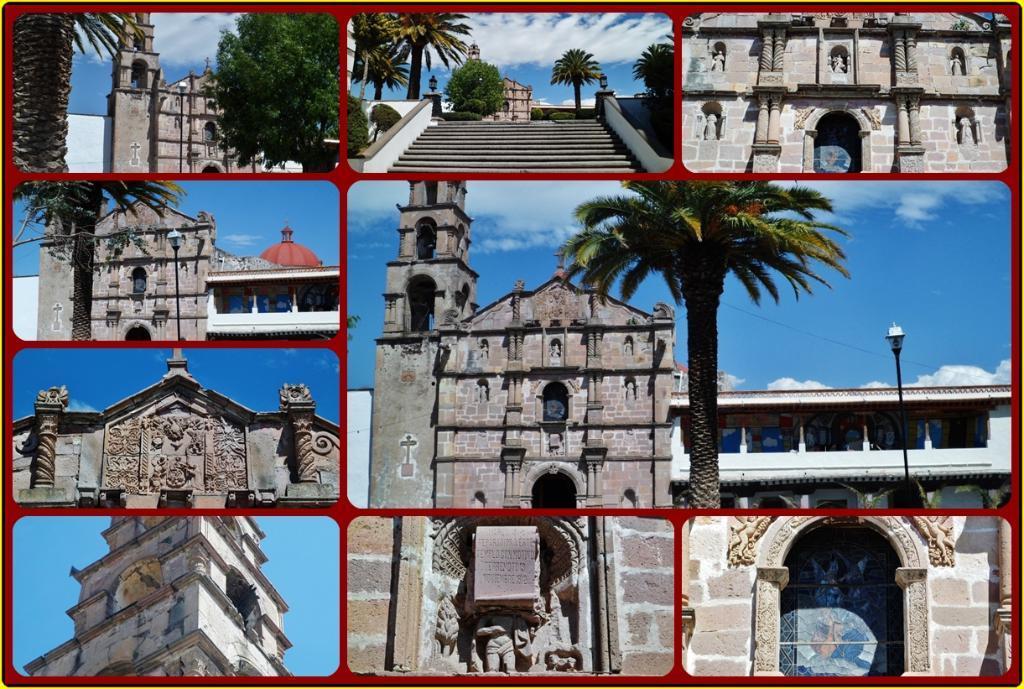How would you summarize this image in a sentence or two? This is a collage image. In this image I can see the buildings, trees, stairs, statues, light pole, clouds and the sky. 